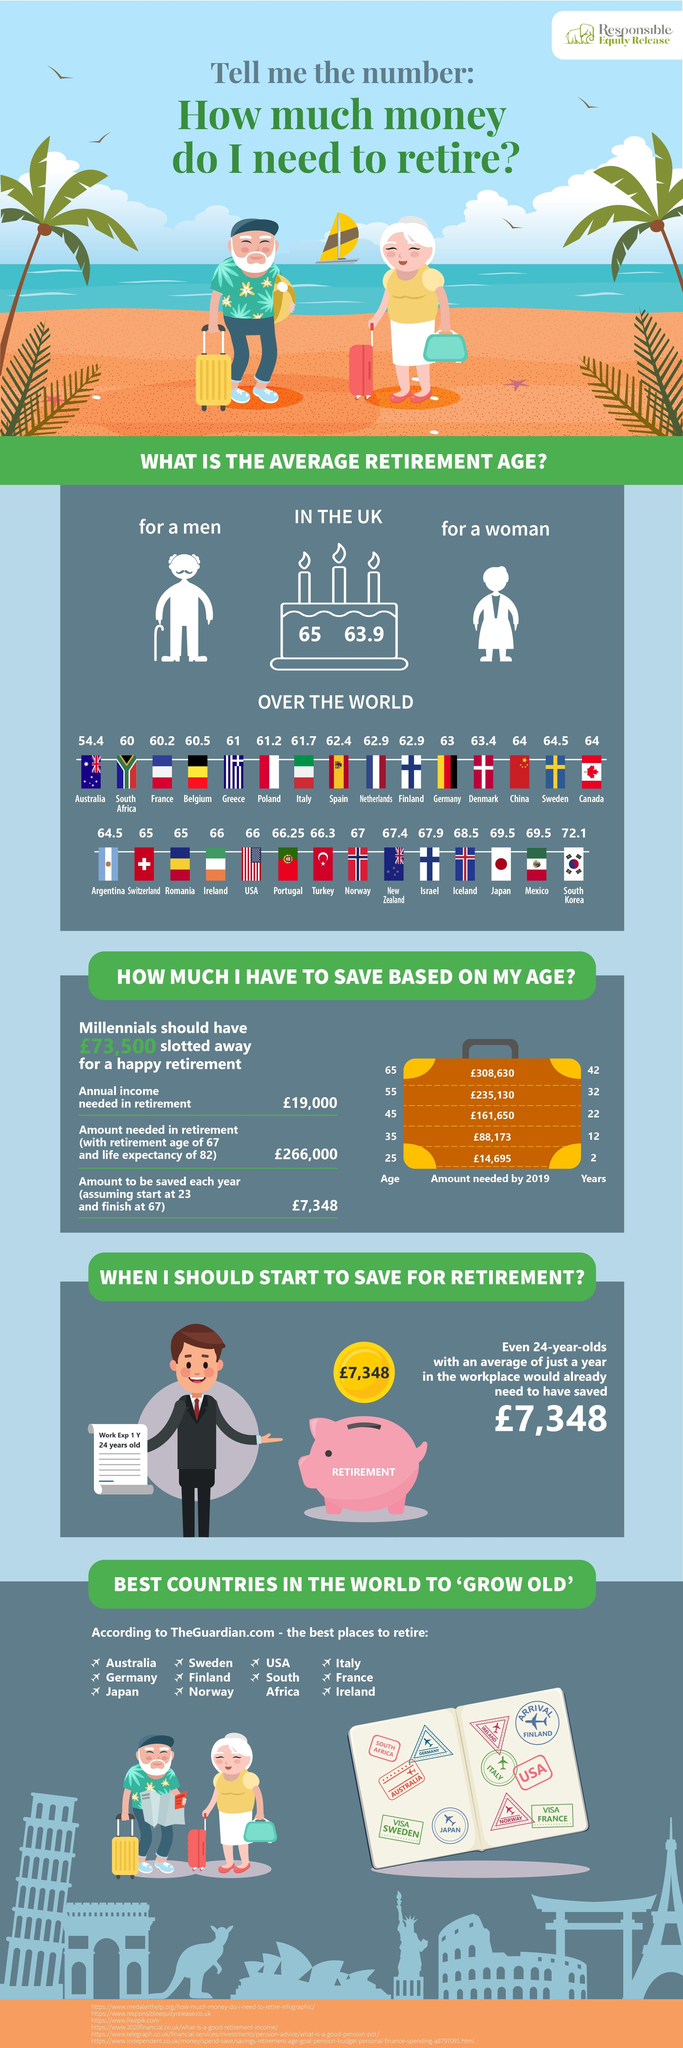Identify some key points in this picture. The average retirement age of people in Norway is 67 years old. The average retirement age of people in Greece is 61. According to data, the average retirement age for women in the UK is 63.9 years old. The average retirement age of people in Italy is 61.7 years. The average retirement age of people in the USA is 66 years old. 